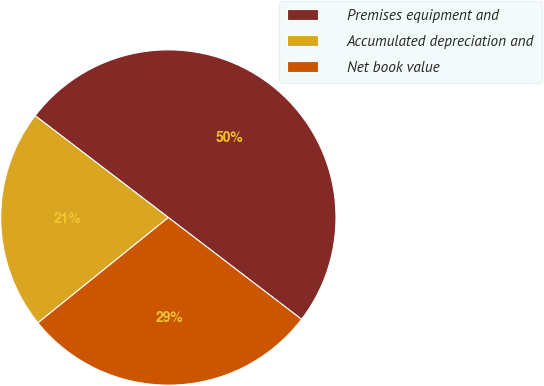<chart> <loc_0><loc_0><loc_500><loc_500><pie_chart><fcel>Premises equipment and<fcel>Accumulated depreciation and<fcel>Net book value<nl><fcel>50.0%<fcel>21.2%<fcel>28.8%<nl></chart> 